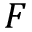Convert formula to latex. <formula><loc_0><loc_0><loc_500><loc_500>F</formula> 